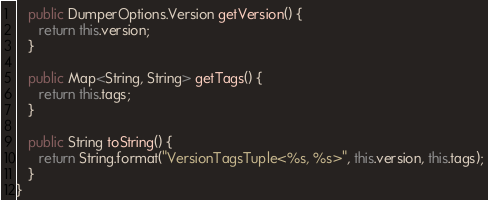<code> <loc_0><loc_0><loc_500><loc_500><_Java_>   public DumperOptions.Version getVersion() {
      return this.version;
   }

   public Map<String, String> getTags() {
      return this.tags;
   }

   public String toString() {
      return String.format("VersionTagsTuple<%s, %s>", this.version, this.tags);
   }
}
</code> 